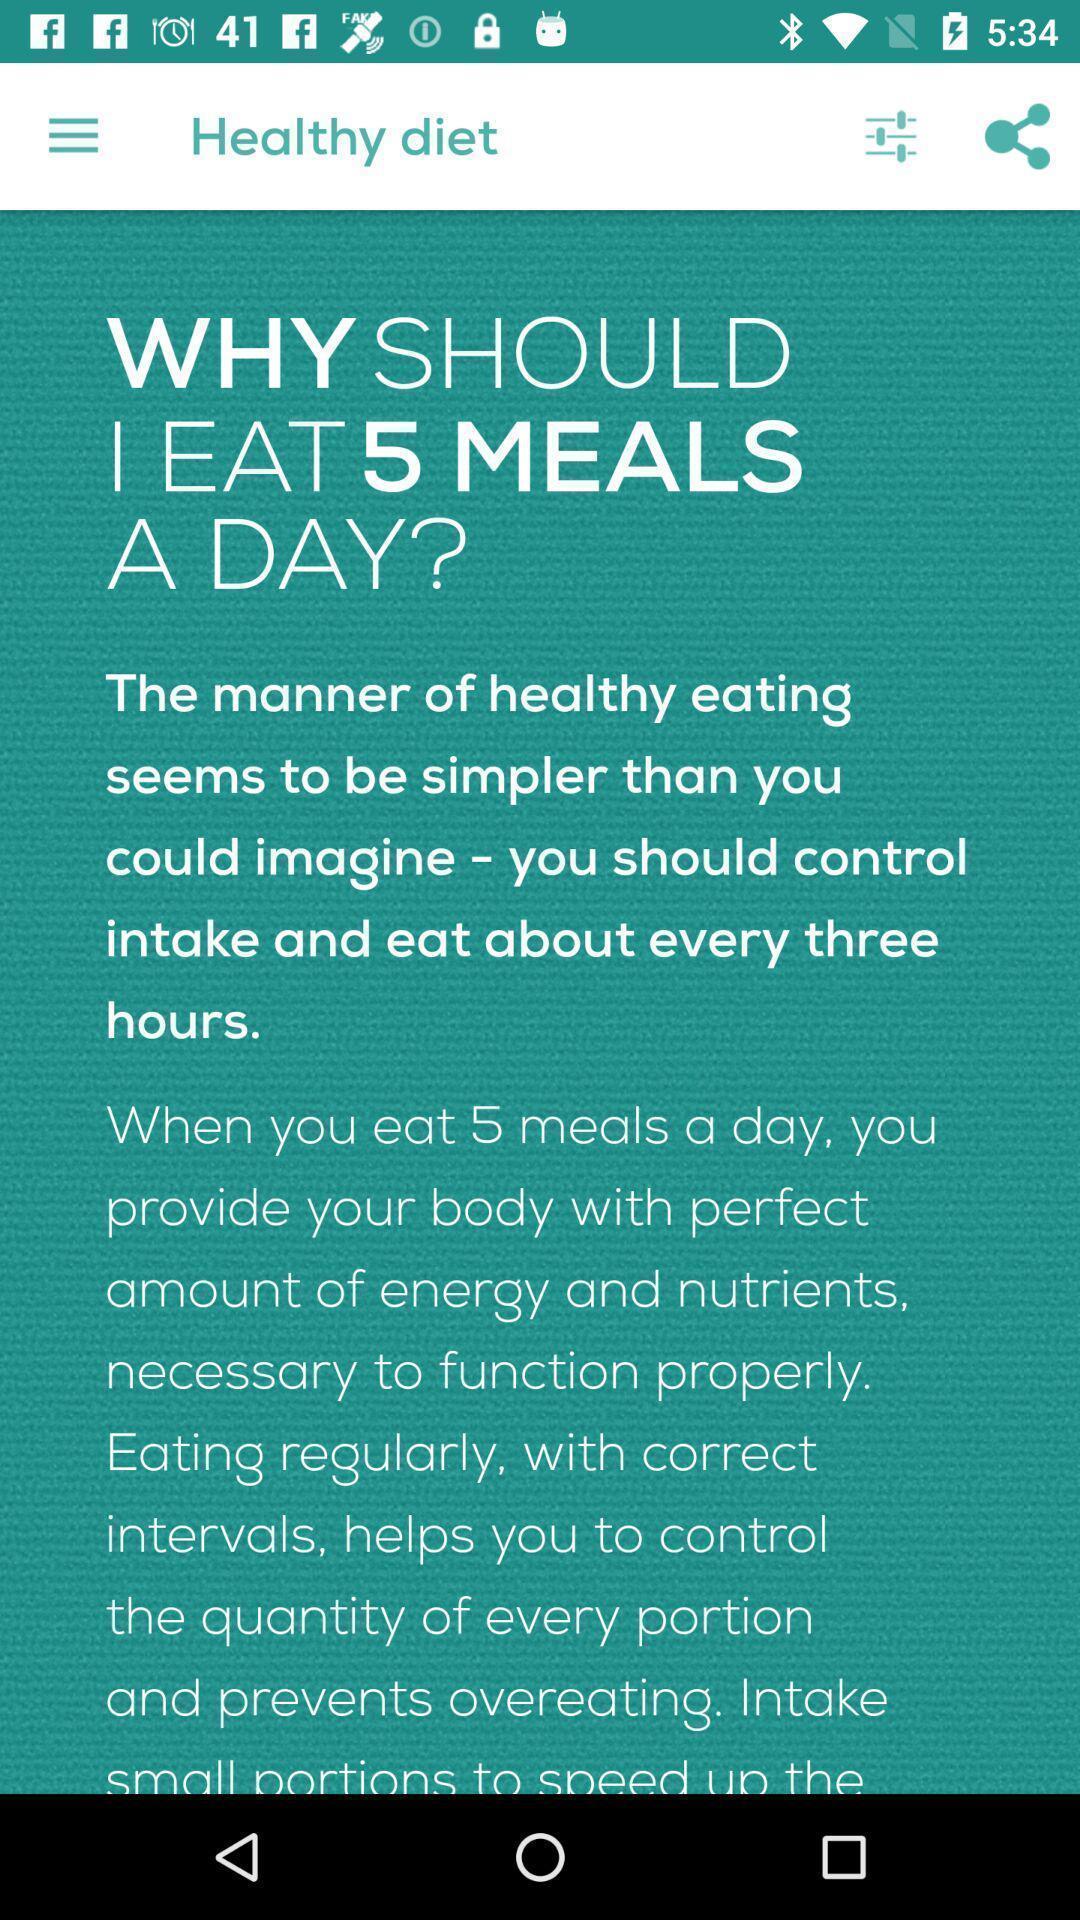Please provide a description for this image. Screen shows information about healthy diet. 